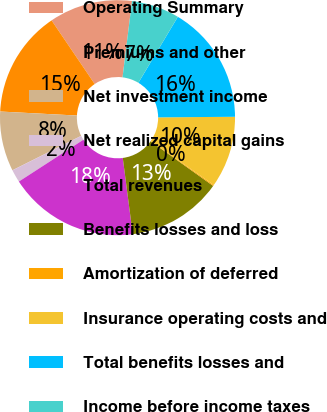<chart> <loc_0><loc_0><loc_500><loc_500><pie_chart><fcel>Operating Summary<fcel>Premiums and other<fcel>Net investment income<fcel>Net realized capital gains<fcel>Total revenues<fcel>Benefits losses and loss<fcel>Amortization of deferred<fcel>Insurance operating costs and<fcel>Total benefits losses and<fcel>Income before income taxes<nl><fcel>11.45%<fcel>14.69%<fcel>8.22%<fcel>1.76%<fcel>17.92%<fcel>13.07%<fcel>0.14%<fcel>9.84%<fcel>16.3%<fcel>6.61%<nl></chart> 